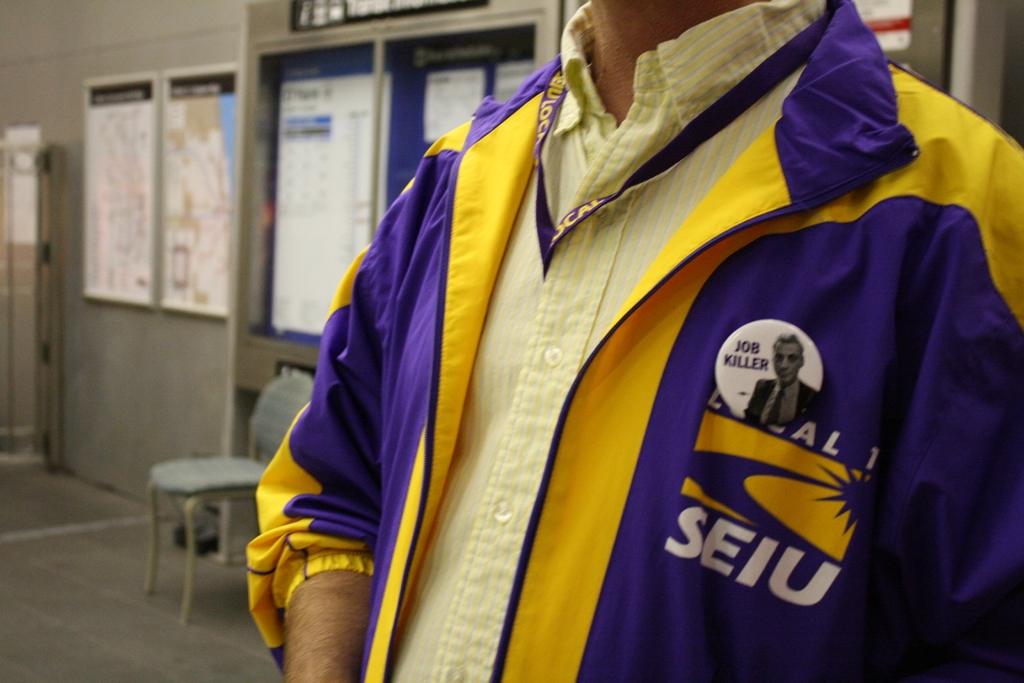What does it say on his jacket?
Provide a short and direct response. Seiu. What is the name of the person on the button pinned to his jacket?
Your answer should be compact. Job killer. 